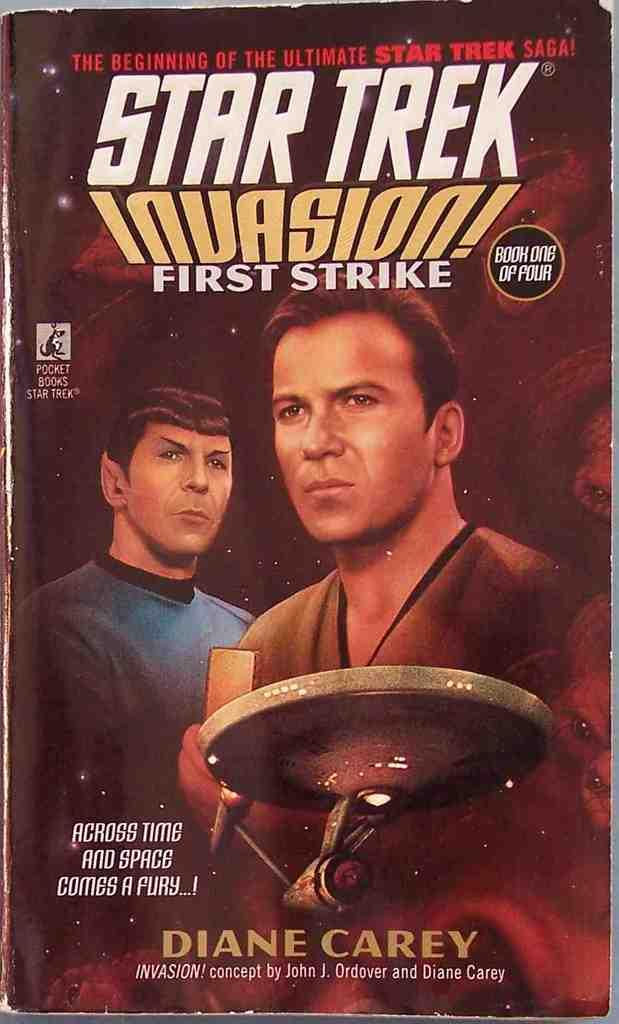<image>
Offer a succinct explanation of the picture presented. Star Trek Invasion first strike saga by Diane Carey 